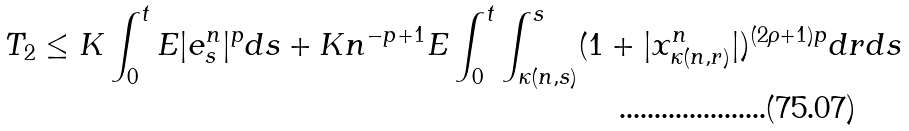<formula> <loc_0><loc_0><loc_500><loc_500>T _ { 2 } \leq K \int _ { 0 } ^ { t } E | e _ { s } ^ { n } | ^ { p } d s + K n ^ { - p + 1 } E \int _ { 0 } ^ { t } \int _ { \kappa ( n , s ) } ^ { s } ( 1 + | x _ { \kappa ( n , r ) } ^ { n } | ) ^ { ( 2 \rho + 1 ) p } d r d s</formula> 